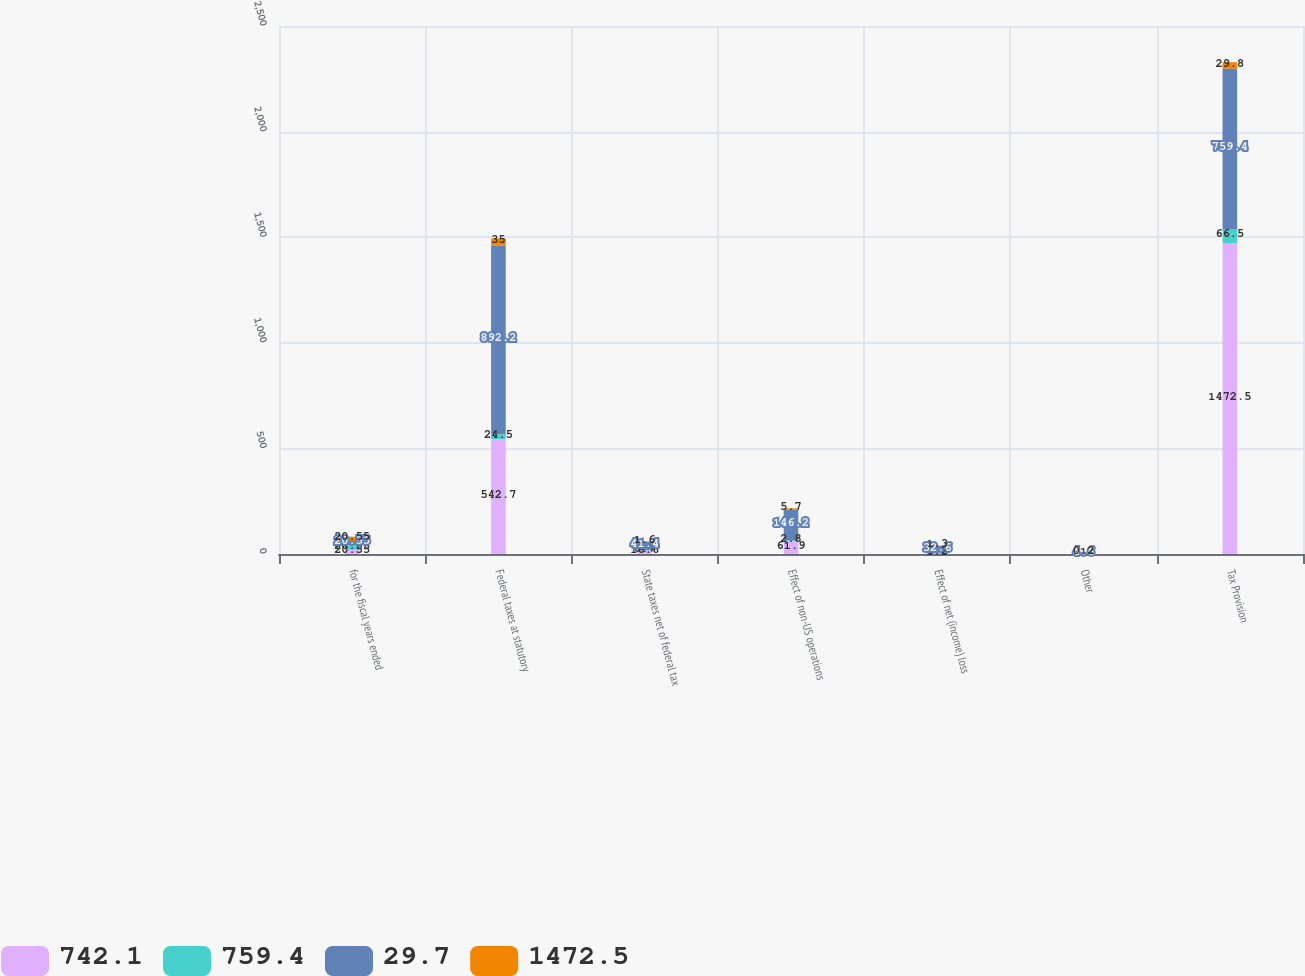Convert chart to OTSL. <chart><loc_0><loc_0><loc_500><loc_500><stacked_bar_chart><ecel><fcel>for the fiscal years ended<fcel>Federal taxes at statutory<fcel>State taxes net of federal tax<fcel>Effect of non-US operations<fcel>Effect of net (income) loss<fcel>Other<fcel>Tax Provision<nl><fcel>742.1<fcel>20.55<fcel>542.7<fcel>16.6<fcel>61.9<fcel>5.3<fcel>1<fcel>1472.5<nl><fcel>759.4<fcel>20.55<fcel>24.5<fcel>0.7<fcel>2.8<fcel>0.2<fcel>0.1<fcel>66.5<nl><fcel>29.7<fcel>20.55<fcel>892.2<fcel>41.4<fcel>146.2<fcel>32.6<fcel>4.6<fcel>759.4<nl><fcel>1472.5<fcel>20.55<fcel>35<fcel>1.6<fcel>5.7<fcel>1.3<fcel>0.2<fcel>29.8<nl></chart> 